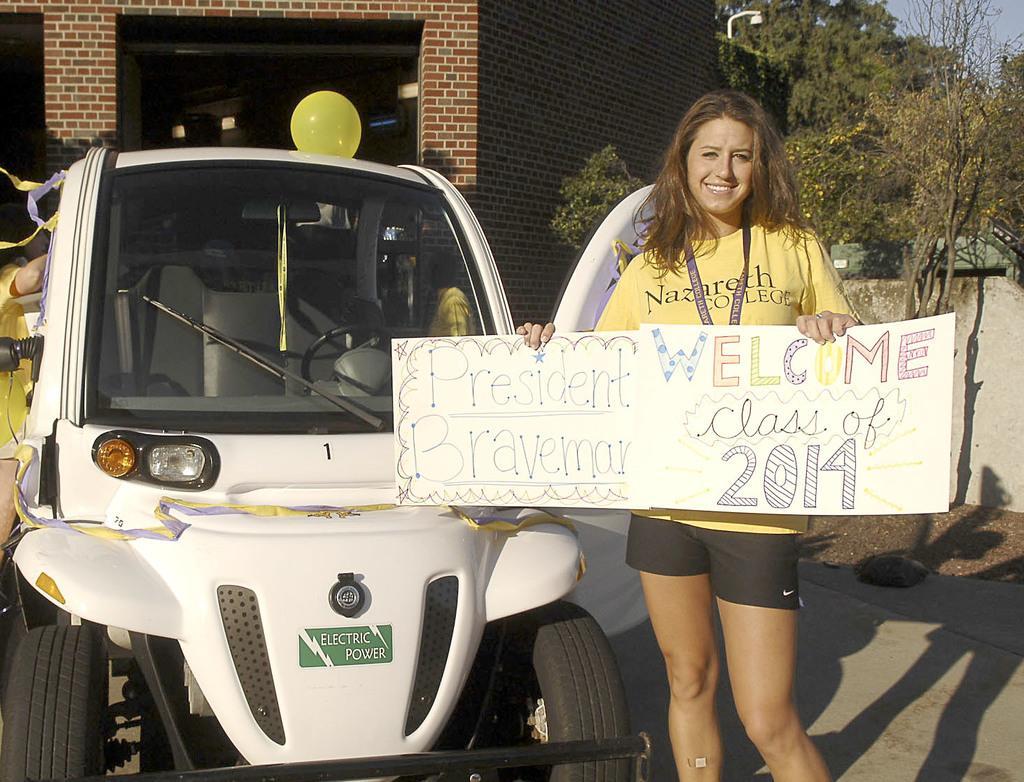How would you summarize this image in a sentence or two? In the background we can see the sky, trees, brick wall and few lights are visible. In this picture we can see a vehicle, color ribbons and a yellow balloon. We can see the people. We can see a woman wearing yellow t-shirt and a tag, she is holding a board in her hand. At the bottom portion of the picture we can see the road. 